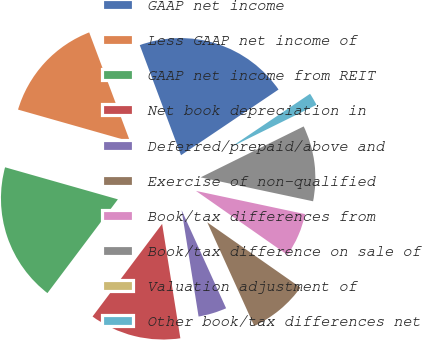Convert chart. <chart><loc_0><loc_0><loc_500><loc_500><pie_chart><fcel>GAAP net income<fcel>Less GAAP net income of<fcel>GAAP net income from REIT<fcel>Net book depreciation in<fcel>Deferred/prepaid/above and<fcel>Exercise of non-qualified<fcel>Book/tax differences from<fcel>Book/tax difference on sale of<fcel>Valuation adjustment of<fcel>Other book/tax differences net<nl><fcel>21.27%<fcel>14.89%<fcel>19.15%<fcel>12.77%<fcel>4.26%<fcel>8.51%<fcel>6.38%<fcel>10.64%<fcel>0.0%<fcel>2.13%<nl></chart> 